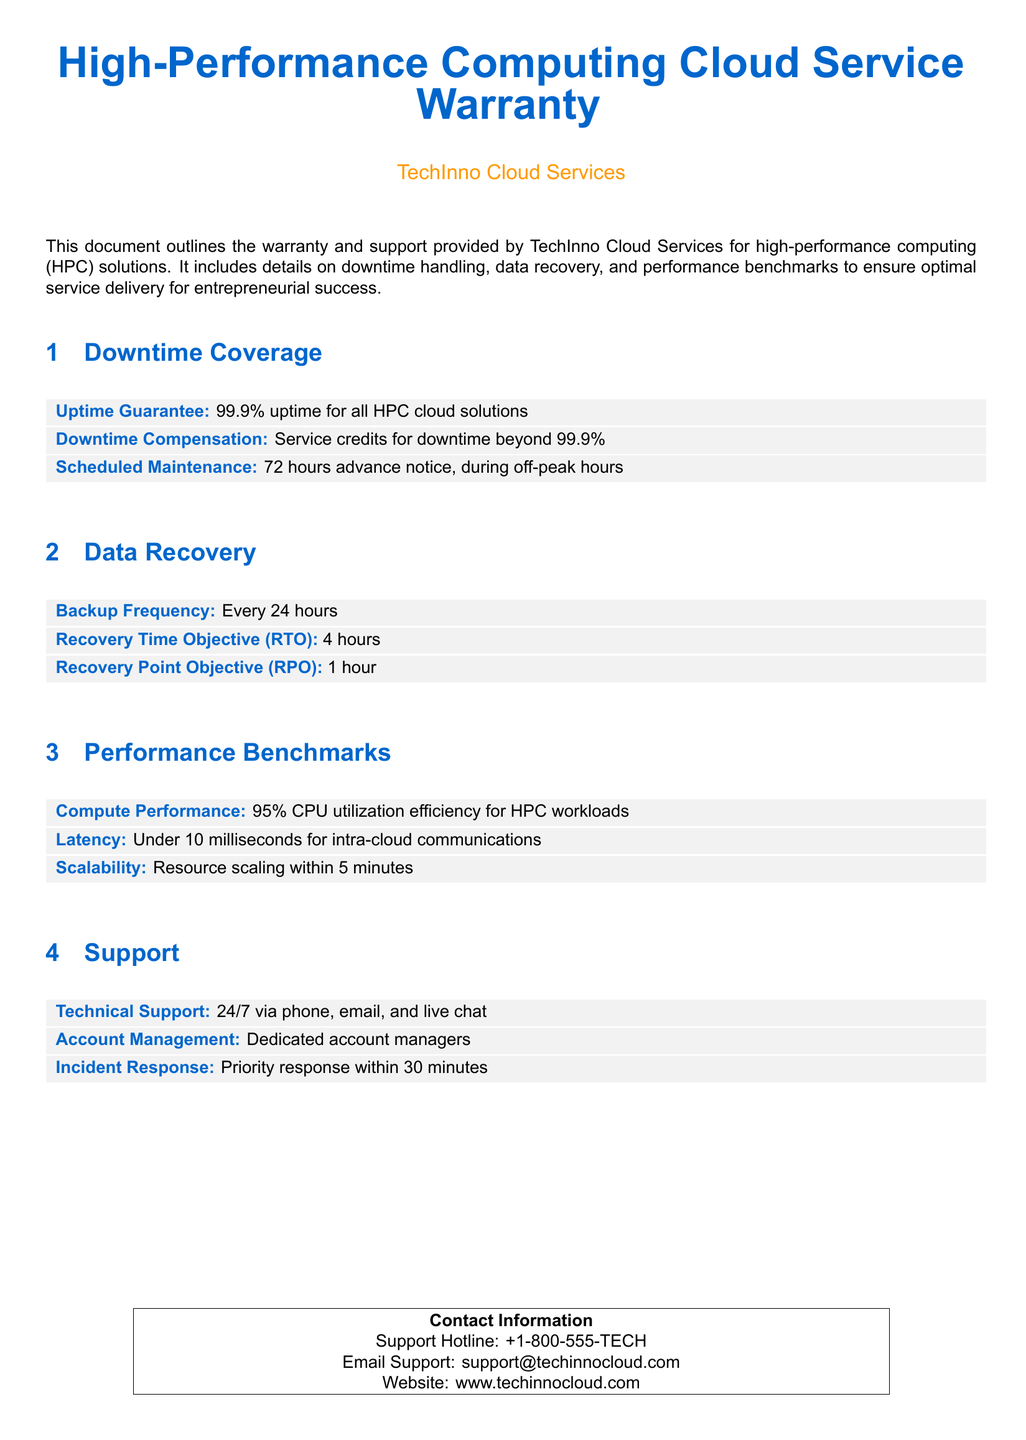What is the uptime guarantee? The uptime guarantee is specified in the "Downtime Coverage" section of the document.
Answer: 99.9% What is the Recovery Time Objective (RTO)? The Recovery Time Objective is mentioned in the "Data Recovery" section of the document.
Answer: 4 hours What type of support is available? The type of support is detailed in the "Support" section, listing multiple means of assistance.
Answer: 24/7 via phone, email, and live chat What is the compensation for downtime beyond the guarantee? The downtime compensation details can be found in the "Downtime Coverage" section.
Answer: Service credits for downtime beyond 99.9% What is the scalability time frame for resource scaling? The scalability time frame is detailed in the "Performance Benchmarks" section.
Answer: Within 5 minutes What is the Backup Frequency? The Backup Frequency is specified in the "Data Recovery" section of the document.
Answer: Every 24 hours What is the latency for intra-cloud communications? The latency information is found in the "Performance Benchmarks" section.
Answer: Under 10 milliseconds 